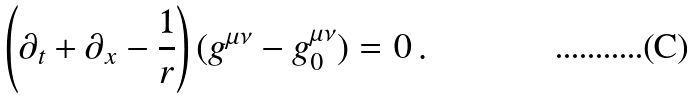<formula> <loc_0><loc_0><loc_500><loc_500>\left ( \partial _ { t } + \partial _ { x } - \frac { 1 } { r } \right ) ( g ^ { \mu \nu } - g ^ { \mu \nu } _ { 0 } ) = 0 \, .</formula> 